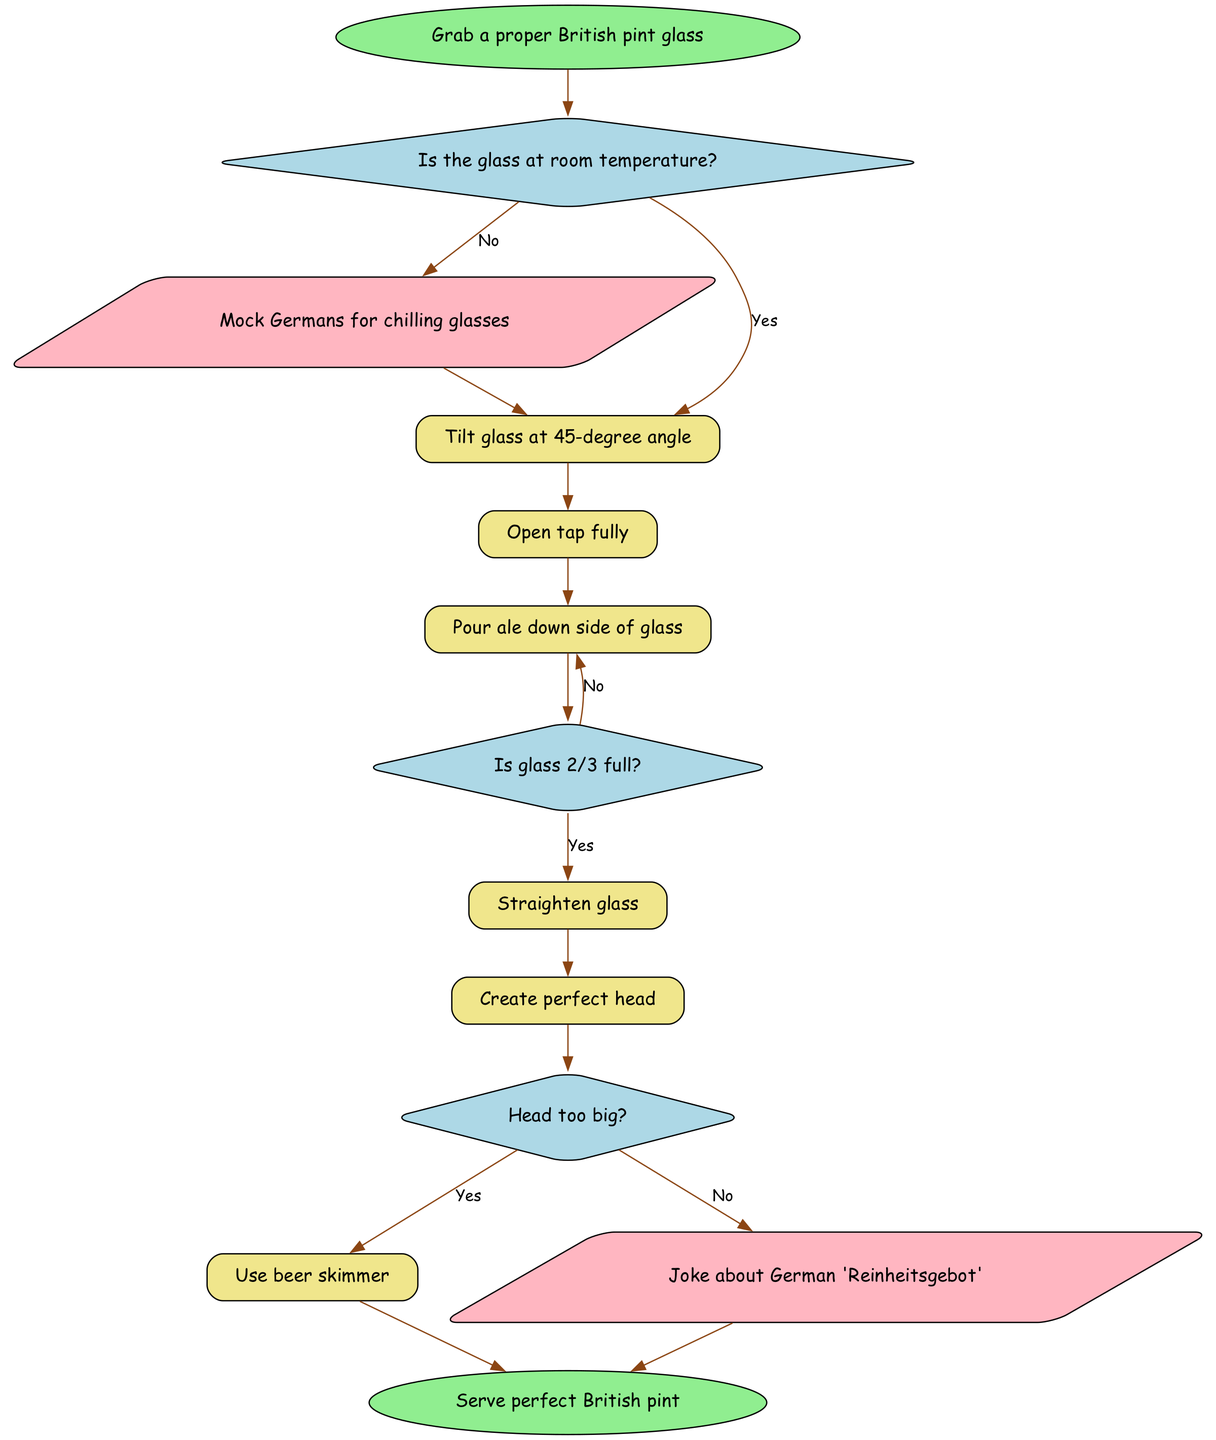What is the first step in pouring a pint? The first step in the diagram states to "Grab a proper British pint glass." This is the starting point of the process.
Answer: Grab a proper British pint glass How many actions follow after the decision of the glass temperature? After the decision about the temperature of the glass, if it's not at room temperature, there is one action (mocking Germans) followed by another action (tilting the glass). If it is at room temperature, it moves directly to the next action (opening the tap). Therefore, there are three actions in total depending on the condition.
Answer: Three What do you do if the glass is not 2/3 full? According to the diagram, if the glass is not 2/3 full, you would go back to pouring ale down the side of the glass. This is indicated by the "No" branch from the decision about the glass's fullness.
Answer: Pour ale down side of glass What happens if the head of the ale is too big? If the head of the ale is too big, the diagram instructs to use a beer skimmer. This action directly follows the decision about the size of the head.
Answer: Use beer skimmer What action precedes creating the perfect head? The action that comes just before creating the perfect head is "Straighten glass." This means after filling the glass to about 2/3, the next step is to straighten it before finishing the pour.
Answer: Straighten glass What is the action associated with mocking German beer laws? The action associated with mocking German beer laws is positioned after the decision about whether the glass is at room temperature and if it is not, and is described as "Mock Germans for chilling glasses." It serves as a humorous commentary within the pouring process.
Answer: Mock Germans for chilling glasses Which decision node follows the action of pouring ale down the side of the glass? Following the action of pouring ale down the side of the glass, the next decision node is about whether the glass is 2/3 full. This node determines the next steps based on the fullness of the pint.
Answer: Is glass 2/3 full? What happens if the head of the ale is not too big? If the head is not too big, the next action is to joke about the German 'Reinheitsgebot.' This indicates a playful transition into discussing beer purity laws instead of adjusting the head size.
Answer: Joke about German 'Reinheitsgebot' 